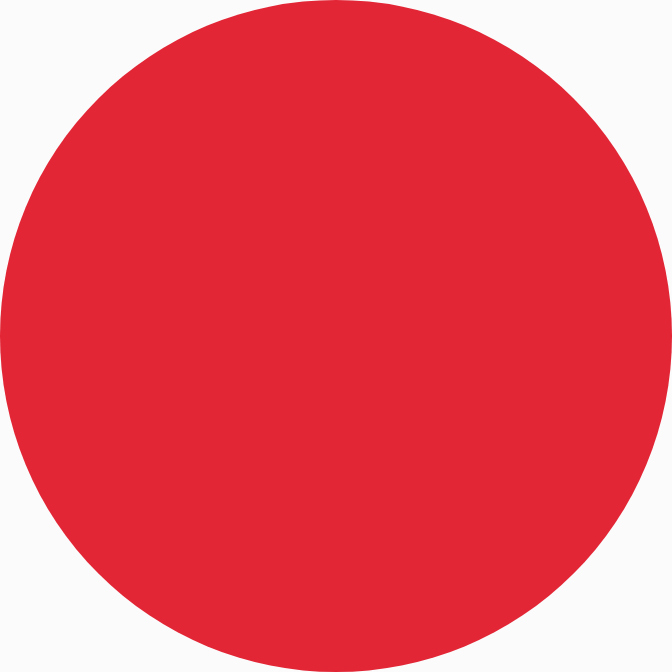Convert chart. <chart><loc_0><loc_0><loc_500><loc_500><pie_chart><ecel><nl><fcel>100.0%<nl></chart> 